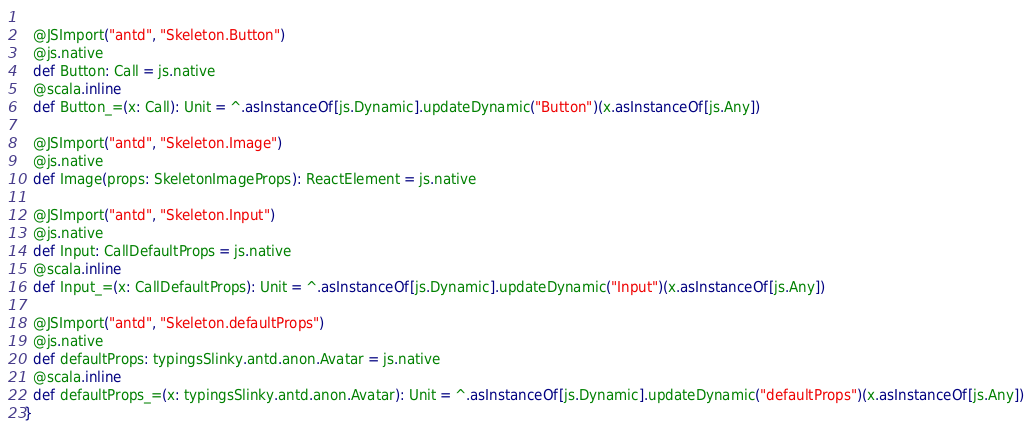Convert code to text. <code><loc_0><loc_0><loc_500><loc_500><_Scala_>  
  @JSImport("antd", "Skeleton.Button")
  @js.native
  def Button: Call = js.native
  @scala.inline
  def Button_=(x: Call): Unit = ^.asInstanceOf[js.Dynamic].updateDynamic("Button")(x.asInstanceOf[js.Any])
  
  @JSImport("antd", "Skeleton.Image")
  @js.native
  def Image(props: SkeletonImageProps): ReactElement = js.native
  
  @JSImport("antd", "Skeleton.Input")
  @js.native
  def Input: CallDefaultProps = js.native
  @scala.inline
  def Input_=(x: CallDefaultProps): Unit = ^.asInstanceOf[js.Dynamic].updateDynamic("Input")(x.asInstanceOf[js.Any])
  
  @JSImport("antd", "Skeleton.defaultProps")
  @js.native
  def defaultProps: typingsSlinky.antd.anon.Avatar = js.native
  @scala.inline
  def defaultProps_=(x: typingsSlinky.antd.anon.Avatar): Unit = ^.asInstanceOf[js.Dynamic].updateDynamic("defaultProps")(x.asInstanceOf[js.Any])
}
</code> 